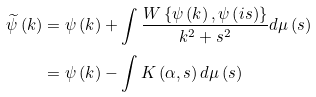Convert formula to latex. <formula><loc_0><loc_0><loc_500><loc_500>\widetilde { \psi } \left ( k \right ) & = \psi \left ( k \right ) + \int \frac { W \left \{ \psi \left ( k \right ) , \psi \left ( i s \right ) \right \} } { k ^ { 2 } + s ^ { 2 } } d \mu \left ( s \right ) \\ & = \psi \left ( k \right ) - \int K \left ( \alpha , s \right ) d \mu \left ( s \right )</formula> 